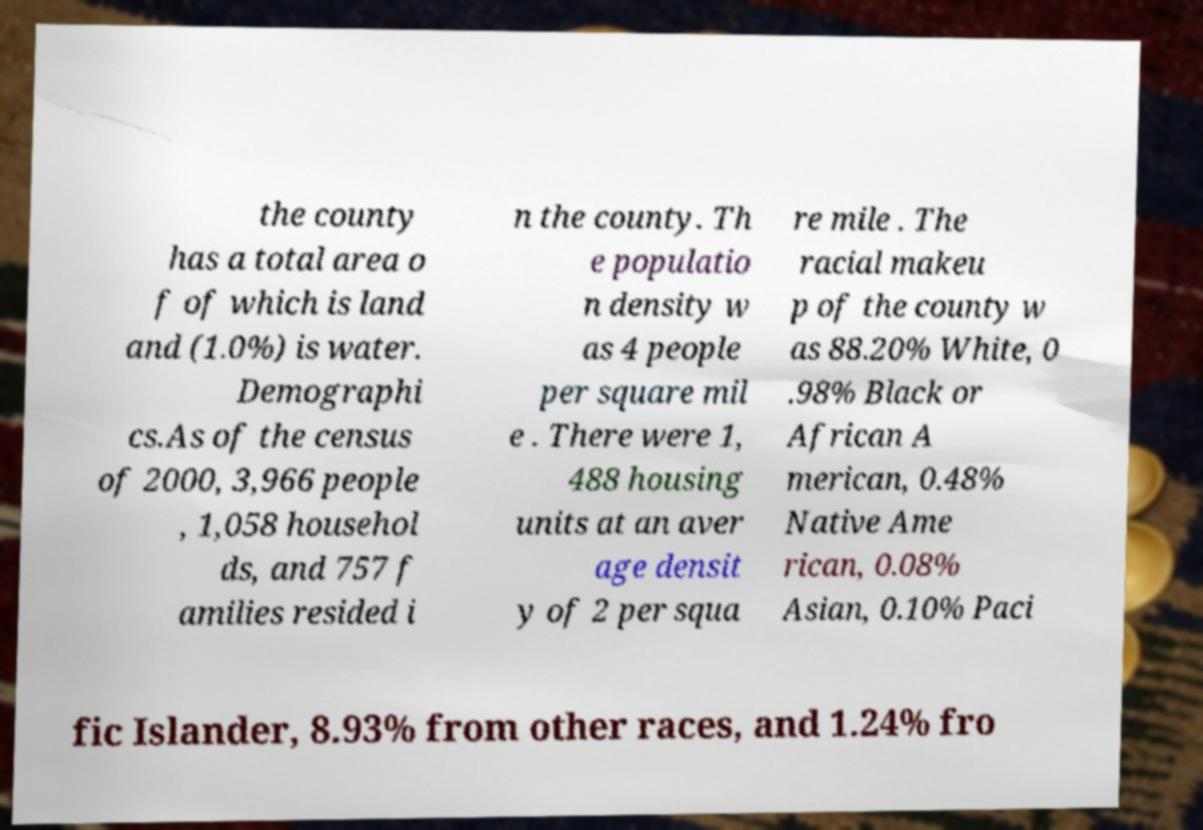I need the written content from this picture converted into text. Can you do that? the county has a total area o f of which is land and (1.0%) is water. Demographi cs.As of the census of 2000, 3,966 people , 1,058 househol ds, and 757 f amilies resided i n the county. Th e populatio n density w as 4 people per square mil e . There were 1, 488 housing units at an aver age densit y of 2 per squa re mile . The racial makeu p of the county w as 88.20% White, 0 .98% Black or African A merican, 0.48% Native Ame rican, 0.08% Asian, 0.10% Paci fic Islander, 8.93% from other races, and 1.24% fro 